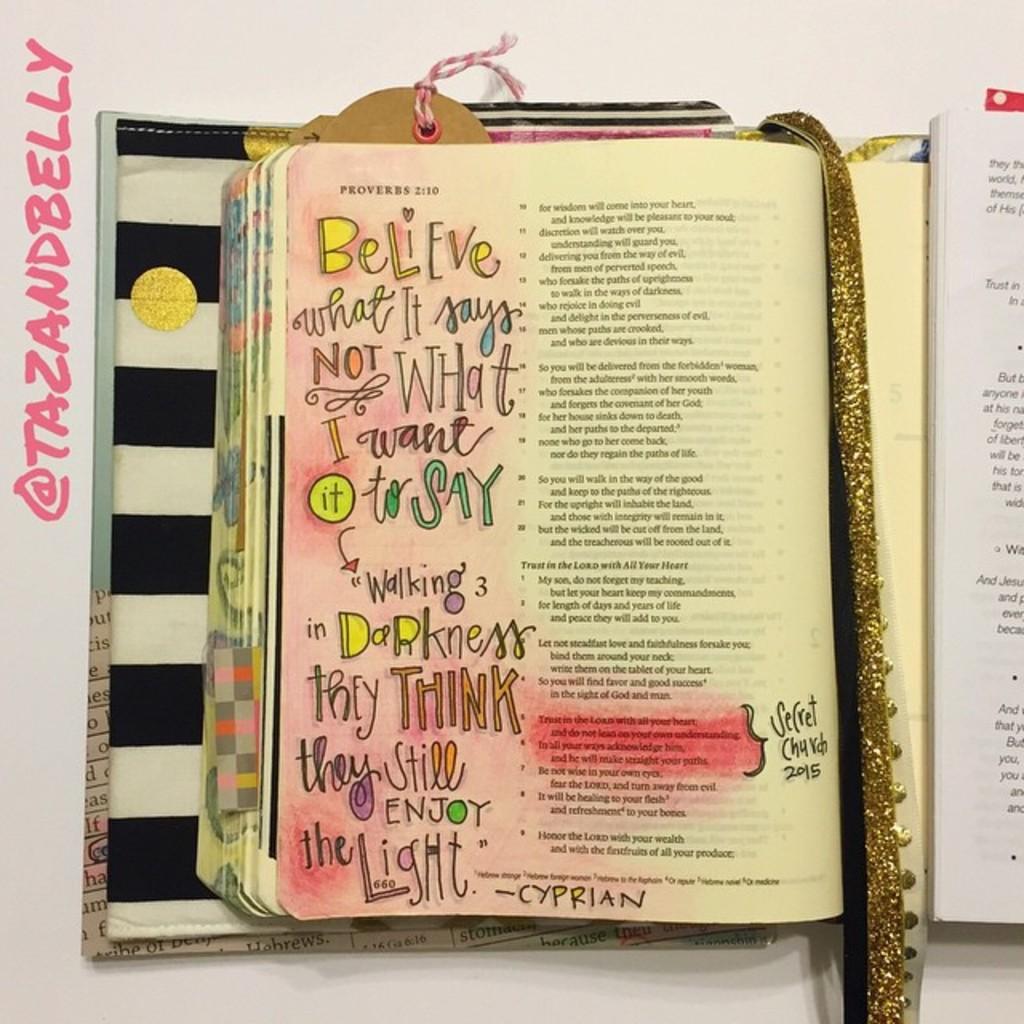In what book of the bible can those passages be found?
Offer a very short reply. Proverbs. Who posted this picture on social media?
Your response must be concise. Tazandbelly. 